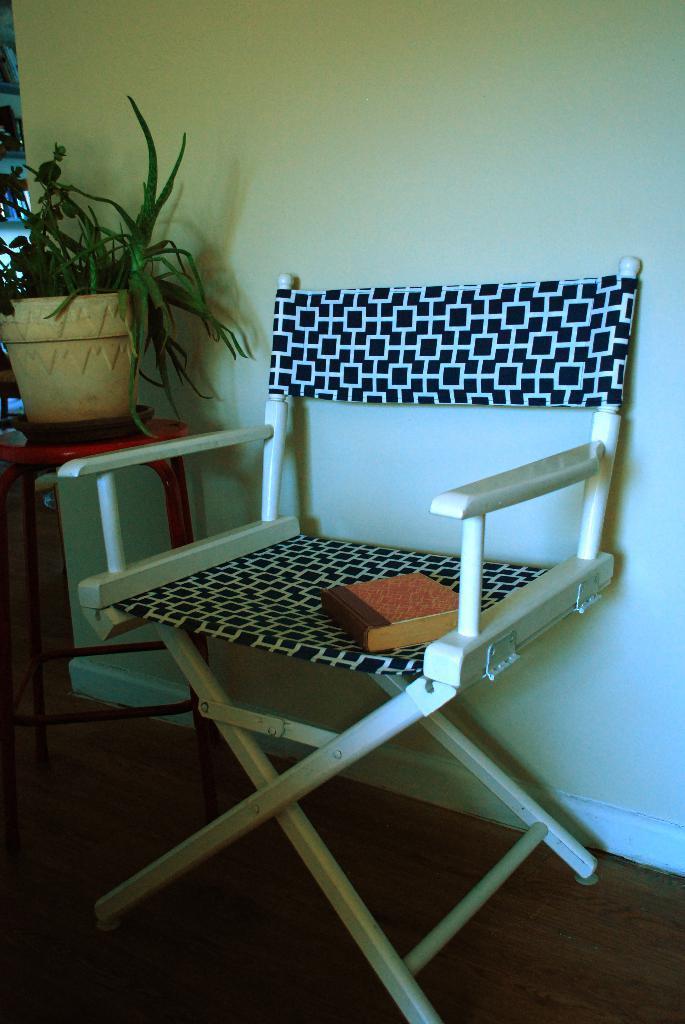Could you give a brief overview of what you see in this image? In this image, In the middle there is a chair which is in white color and there is a black color cloth on the chair, In the left side there is a flower box and there is a green color plant. 